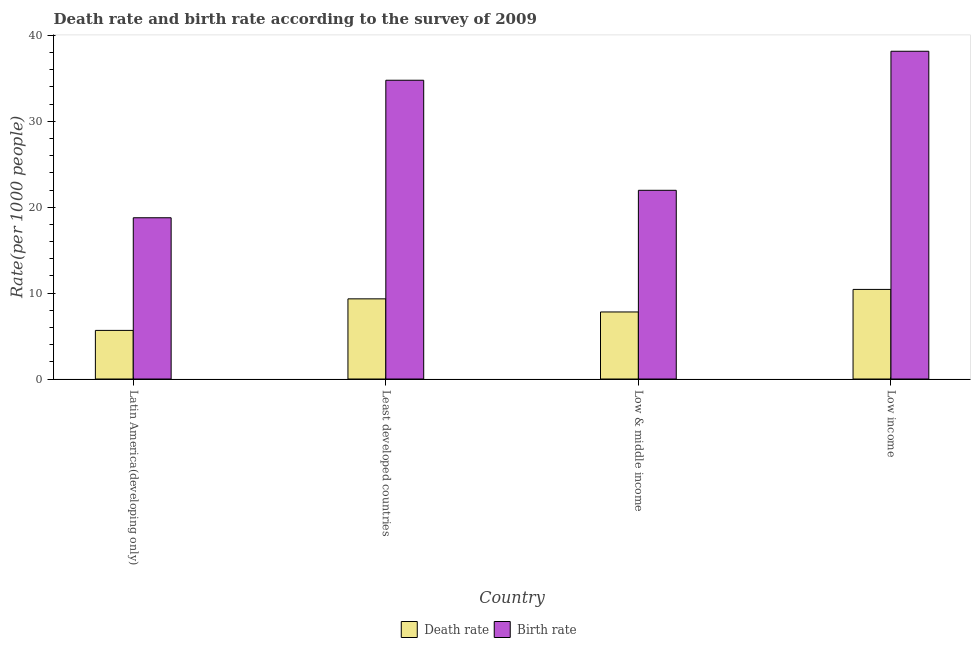How many groups of bars are there?
Keep it short and to the point. 4. How many bars are there on the 2nd tick from the left?
Your answer should be compact. 2. How many bars are there on the 2nd tick from the right?
Keep it short and to the point. 2. What is the label of the 4th group of bars from the left?
Keep it short and to the point. Low income. What is the death rate in Low income?
Your response must be concise. 10.43. Across all countries, what is the maximum death rate?
Ensure brevity in your answer.  10.43. Across all countries, what is the minimum birth rate?
Ensure brevity in your answer.  18.77. In which country was the birth rate minimum?
Offer a very short reply. Latin America(developing only). What is the total death rate in the graph?
Provide a succinct answer. 33.23. What is the difference between the birth rate in Least developed countries and that in Low income?
Offer a terse response. -3.37. What is the difference between the birth rate in Latin America(developing only) and the death rate in Low & middle income?
Give a very brief answer. 10.97. What is the average birth rate per country?
Make the answer very short. 28.42. What is the difference between the death rate and birth rate in Low & middle income?
Provide a succinct answer. -14.16. What is the ratio of the death rate in Latin America(developing only) to that in Low income?
Your answer should be compact. 0.54. Is the birth rate in Least developed countries less than that in Low income?
Keep it short and to the point. Yes. What is the difference between the highest and the second highest death rate?
Give a very brief answer. 1.1. What is the difference between the highest and the lowest death rate?
Give a very brief answer. 4.77. In how many countries, is the birth rate greater than the average birth rate taken over all countries?
Ensure brevity in your answer.  2. What does the 1st bar from the left in Latin America(developing only) represents?
Provide a short and direct response. Death rate. What does the 1st bar from the right in Latin America(developing only) represents?
Give a very brief answer. Birth rate. How many bars are there?
Your answer should be compact. 8. How many countries are there in the graph?
Make the answer very short. 4. Are the values on the major ticks of Y-axis written in scientific E-notation?
Keep it short and to the point. No. Does the graph contain any zero values?
Give a very brief answer. No. Does the graph contain grids?
Provide a succinct answer. No. Where does the legend appear in the graph?
Make the answer very short. Bottom center. How are the legend labels stacked?
Give a very brief answer. Horizontal. What is the title of the graph?
Your answer should be very brief. Death rate and birth rate according to the survey of 2009. What is the label or title of the Y-axis?
Offer a terse response. Rate(per 1000 people). What is the Rate(per 1000 people) in Death rate in Latin America(developing only)?
Your answer should be compact. 5.66. What is the Rate(per 1000 people) in Birth rate in Latin America(developing only)?
Provide a succinct answer. 18.77. What is the Rate(per 1000 people) in Death rate in Least developed countries?
Your answer should be compact. 9.33. What is the Rate(per 1000 people) in Birth rate in Least developed countries?
Provide a short and direct response. 34.78. What is the Rate(per 1000 people) in Death rate in Low & middle income?
Provide a succinct answer. 7.81. What is the Rate(per 1000 people) in Birth rate in Low & middle income?
Give a very brief answer. 21.97. What is the Rate(per 1000 people) in Death rate in Low income?
Provide a succinct answer. 10.43. What is the Rate(per 1000 people) of Birth rate in Low income?
Offer a very short reply. 38.16. Across all countries, what is the maximum Rate(per 1000 people) in Death rate?
Provide a short and direct response. 10.43. Across all countries, what is the maximum Rate(per 1000 people) of Birth rate?
Your response must be concise. 38.16. Across all countries, what is the minimum Rate(per 1000 people) of Death rate?
Make the answer very short. 5.66. Across all countries, what is the minimum Rate(per 1000 people) in Birth rate?
Your answer should be compact. 18.77. What is the total Rate(per 1000 people) in Death rate in the graph?
Offer a very short reply. 33.23. What is the total Rate(per 1000 people) in Birth rate in the graph?
Keep it short and to the point. 113.68. What is the difference between the Rate(per 1000 people) in Death rate in Latin America(developing only) and that in Least developed countries?
Offer a terse response. -3.67. What is the difference between the Rate(per 1000 people) of Birth rate in Latin America(developing only) and that in Least developed countries?
Your response must be concise. -16.01. What is the difference between the Rate(per 1000 people) of Death rate in Latin America(developing only) and that in Low & middle income?
Provide a short and direct response. -2.15. What is the difference between the Rate(per 1000 people) in Birth rate in Latin America(developing only) and that in Low & middle income?
Provide a short and direct response. -3.19. What is the difference between the Rate(per 1000 people) in Death rate in Latin America(developing only) and that in Low income?
Provide a short and direct response. -4.77. What is the difference between the Rate(per 1000 people) of Birth rate in Latin America(developing only) and that in Low income?
Provide a succinct answer. -19.38. What is the difference between the Rate(per 1000 people) in Death rate in Least developed countries and that in Low & middle income?
Offer a terse response. 1.53. What is the difference between the Rate(per 1000 people) in Birth rate in Least developed countries and that in Low & middle income?
Ensure brevity in your answer.  12.81. What is the difference between the Rate(per 1000 people) of Death rate in Least developed countries and that in Low income?
Ensure brevity in your answer.  -1.1. What is the difference between the Rate(per 1000 people) of Birth rate in Least developed countries and that in Low income?
Provide a succinct answer. -3.37. What is the difference between the Rate(per 1000 people) in Death rate in Low & middle income and that in Low income?
Give a very brief answer. -2.62. What is the difference between the Rate(per 1000 people) of Birth rate in Low & middle income and that in Low income?
Your answer should be compact. -16.19. What is the difference between the Rate(per 1000 people) of Death rate in Latin America(developing only) and the Rate(per 1000 people) of Birth rate in Least developed countries?
Your response must be concise. -29.12. What is the difference between the Rate(per 1000 people) in Death rate in Latin America(developing only) and the Rate(per 1000 people) in Birth rate in Low & middle income?
Make the answer very short. -16.31. What is the difference between the Rate(per 1000 people) in Death rate in Latin America(developing only) and the Rate(per 1000 people) in Birth rate in Low income?
Your answer should be compact. -32.5. What is the difference between the Rate(per 1000 people) of Death rate in Least developed countries and the Rate(per 1000 people) of Birth rate in Low & middle income?
Make the answer very short. -12.64. What is the difference between the Rate(per 1000 people) in Death rate in Least developed countries and the Rate(per 1000 people) in Birth rate in Low income?
Offer a terse response. -28.82. What is the difference between the Rate(per 1000 people) of Death rate in Low & middle income and the Rate(per 1000 people) of Birth rate in Low income?
Provide a short and direct response. -30.35. What is the average Rate(per 1000 people) in Death rate per country?
Your answer should be very brief. 8.31. What is the average Rate(per 1000 people) of Birth rate per country?
Give a very brief answer. 28.42. What is the difference between the Rate(per 1000 people) of Death rate and Rate(per 1000 people) of Birth rate in Latin America(developing only)?
Offer a terse response. -13.11. What is the difference between the Rate(per 1000 people) of Death rate and Rate(per 1000 people) of Birth rate in Least developed countries?
Your answer should be compact. -25.45. What is the difference between the Rate(per 1000 people) in Death rate and Rate(per 1000 people) in Birth rate in Low & middle income?
Your answer should be very brief. -14.16. What is the difference between the Rate(per 1000 people) of Death rate and Rate(per 1000 people) of Birth rate in Low income?
Provide a succinct answer. -27.73. What is the ratio of the Rate(per 1000 people) of Death rate in Latin America(developing only) to that in Least developed countries?
Ensure brevity in your answer.  0.61. What is the ratio of the Rate(per 1000 people) of Birth rate in Latin America(developing only) to that in Least developed countries?
Offer a very short reply. 0.54. What is the ratio of the Rate(per 1000 people) of Death rate in Latin America(developing only) to that in Low & middle income?
Make the answer very short. 0.72. What is the ratio of the Rate(per 1000 people) of Birth rate in Latin America(developing only) to that in Low & middle income?
Your answer should be compact. 0.85. What is the ratio of the Rate(per 1000 people) in Death rate in Latin America(developing only) to that in Low income?
Offer a terse response. 0.54. What is the ratio of the Rate(per 1000 people) in Birth rate in Latin America(developing only) to that in Low income?
Make the answer very short. 0.49. What is the ratio of the Rate(per 1000 people) in Death rate in Least developed countries to that in Low & middle income?
Your answer should be compact. 1.2. What is the ratio of the Rate(per 1000 people) of Birth rate in Least developed countries to that in Low & middle income?
Your answer should be compact. 1.58. What is the ratio of the Rate(per 1000 people) in Death rate in Least developed countries to that in Low income?
Your answer should be compact. 0.89. What is the ratio of the Rate(per 1000 people) in Birth rate in Least developed countries to that in Low income?
Your response must be concise. 0.91. What is the ratio of the Rate(per 1000 people) in Death rate in Low & middle income to that in Low income?
Your answer should be very brief. 0.75. What is the ratio of the Rate(per 1000 people) of Birth rate in Low & middle income to that in Low income?
Keep it short and to the point. 0.58. What is the difference between the highest and the second highest Rate(per 1000 people) in Death rate?
Ensure brevity in your answer.  1.1. What is the difference between the highest and the second highest Rate(per 1000 people) in Birth rate?
Provide a short and direct response. 3.37. What is the difference between the highest and the lowest Rate(per 1000 people) of Death rate?
Offer a terse response. 4.77. What is the difference between the highest and the lowest Rate(per 1000 people) in Birth rate?
Ensure brevity in your answer.  19.38. 